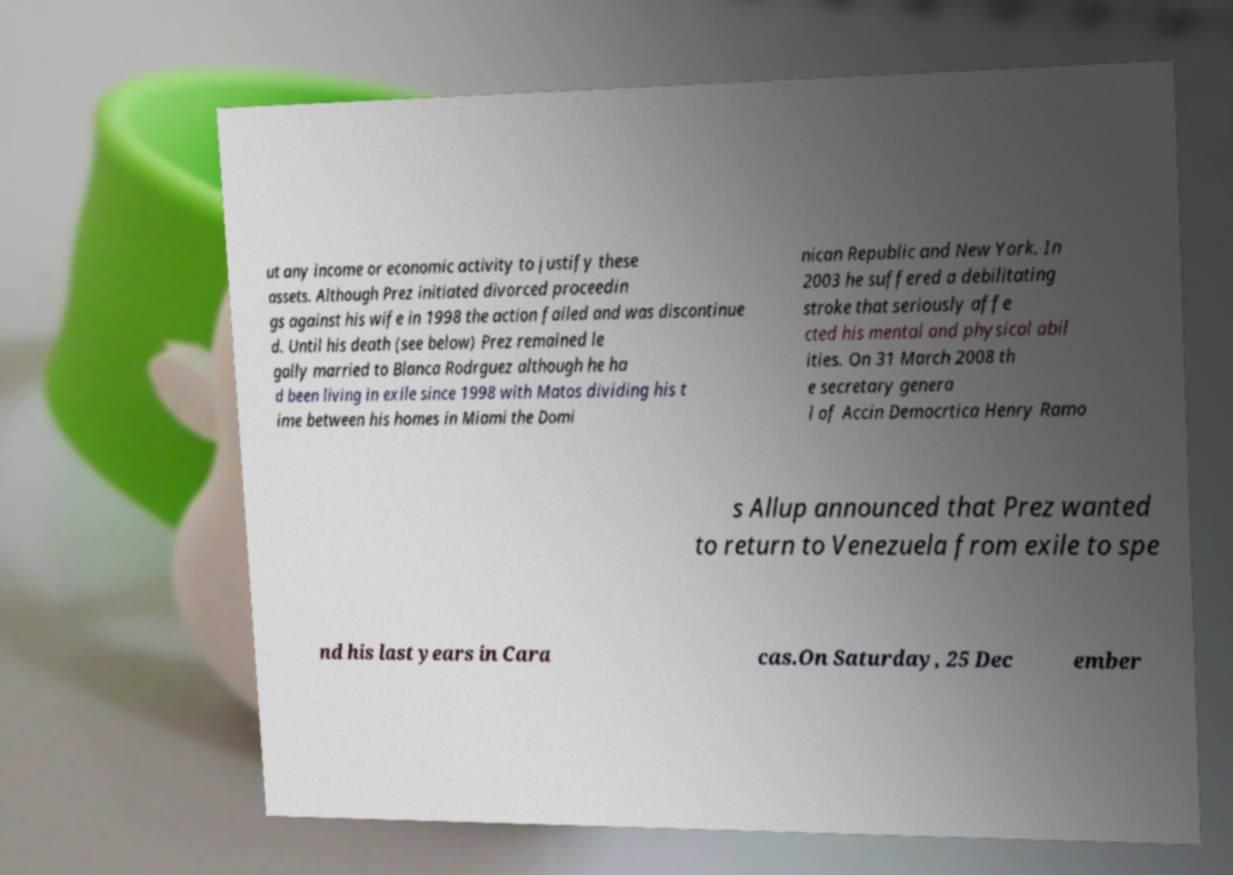I need the written content from this picture converted into text. Can you do that? ut any income or economic activity to justify these assets. Although Prez initiated divorced proceedin gs against his wife in 1998 the action failed and was discontinue d. Until his death (see below) Prez remained le gally married to Blanca Rodrguez although he ha d been living in exile since 1998 with Matos dividing his t ime between his homes in Miami the Domi nican Republic and New York. In 2003 he suffered a debilitating stroke that seriously affe cted his mental and physical abil ities. On 31 March 2008 th e secretary genera l of Accin Democrtica Henry Ramo s Allup announced that Prez wanted to return to Venezuela from exile to spe nd his last years in Cara cas.On Saturday, 25 Dec ember 